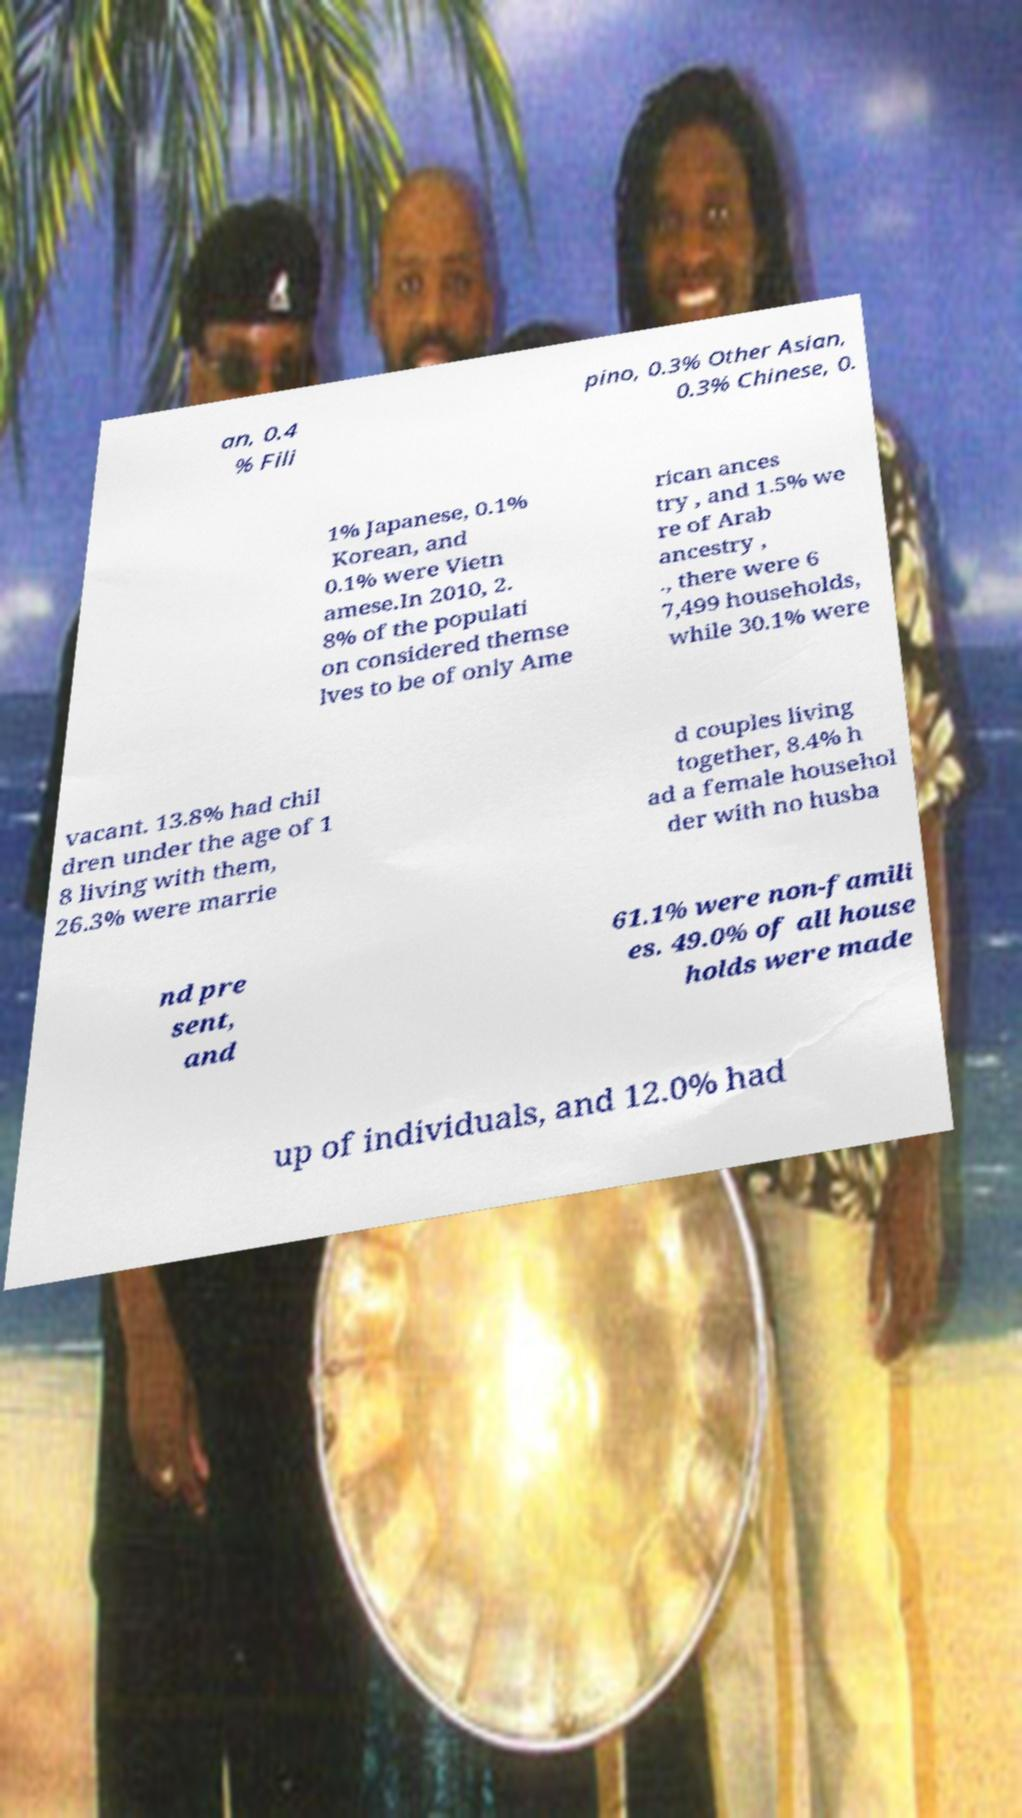Can you read and provide the text displayed in the image?This photo seems to have some interesting text. Can you extract and type it out for me? an, 0.4 % Fili pino, 0.3% Other Asian, 0.3% Chinese, 0. 1% Japanese, 0.1% Korean, and 0.1% were Vietn amese.In 2010, 2. 8% of the populati on considered themse lves to be of only Ame rican ances try , and 1.5% we re of Arab ancestry , ., there were 6 7,499 households, while 30.1% were vacant. 13.8% had chil dren under the age of 1 8 living with them, 26.3% were marrie d couples living together, 8.4% h ad a female househol der with no husba nd pre sent, and 61.1% were non-famili es. 49.0% of all house holds were made up of individuals, and 12.0% had 